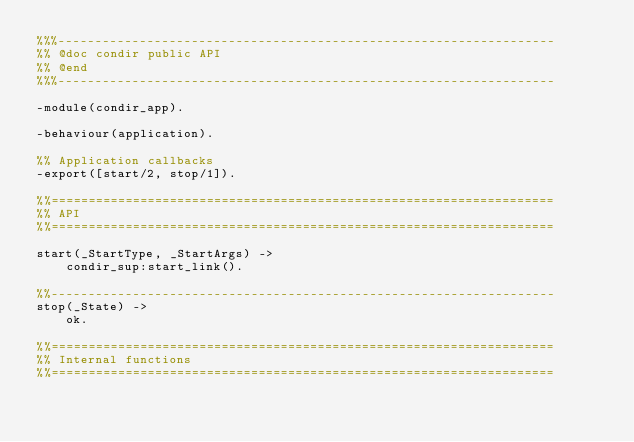Convert code to text. <code><loc_0><loc_0><loc_500><loc_500><_Erlang_>%%%-------------------------------------------------------------------
%% @doc condir public API
%% @end
%%%-------------------------------------------------------------------

-module(condir_app).

-behaviour(application).

%% Application callbacks
-export([start/2, stop/1]).

%%====================================================================
%% API
%%====================================================================

start(_StartType, _StartArgs) ->
    condir_sup:start_link().

%%--------------------------------------------------------------------
stop(_State) ->
    ok.

%%====================================================================
%% Internal functions
%%====================================================================
</code> 